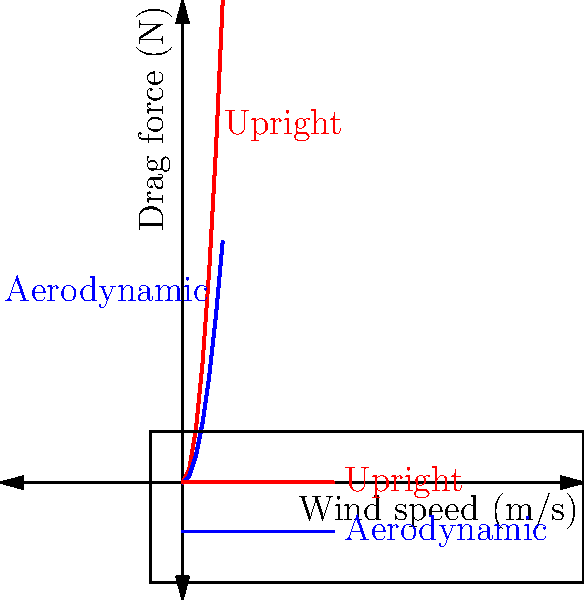Based on the wind tunnel simulation graphic, at what wind speed does the aerodynamic body position of a cyclist reduce drag force by approximately 50% compared to the upright position? To answer this question, we need to analyze the graph and compare the drag forces for both positions at various wind speeds. Let's follow these steps:

1. Observe that the red line represents the upright position, while the blue line represents the aerodynamic position.

2. We're looking for a point where the drag force in the aerodynamic position is about half of the drag force in the upright position.

3. Let's check the values at different wind speeds:
   - At 5 m/s: Upright ≈ 10 N, Aerodynamic ≈ 5 N
   - At 10 m/s: Upright ≈ 40 N, Aerodynamic ≈ 20 N
   - At 15 m/s: Upright ≈ 90 N, Aerodynamic ≈ 45 N
   - At 20 m/s: Upright ≈ 160 N, Aerodynamic ≈ 80 N
   - At 25 m/s: Upright ≈ 250 N, Aerodynamic ≈ 125 N
   - At 30 m/s: Upright ≈ 360 N, Aerodynamic ≈ 180 N

4. We can see that at each of these points, the aerodynamic position results in approximately half the drag force of the upright position.

5. This relationship holds true across the entire range of wind speeds shown in the graph.

Therefore, the aerodynamic body position reduces drag force by approximately 50% compared to the upright position at all wind speeds shown in the simulation.
Answer: All wind speeds shown (0-30 m/s) 